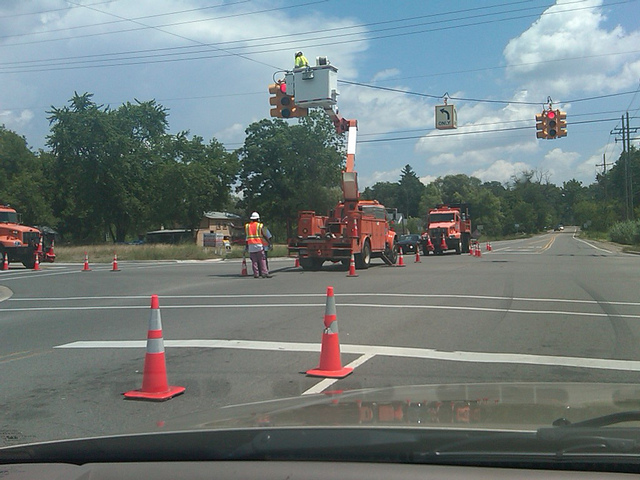Read and extract the text from this image. ONLY 